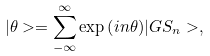<formula> <loc_0><loc_0><loc_500><loc_500>| \theta > = \sum _ { - \infty } ^ { \infty } \exp { \left ( i n \theta \right ) } | G S _ { n } > ,</formula> 